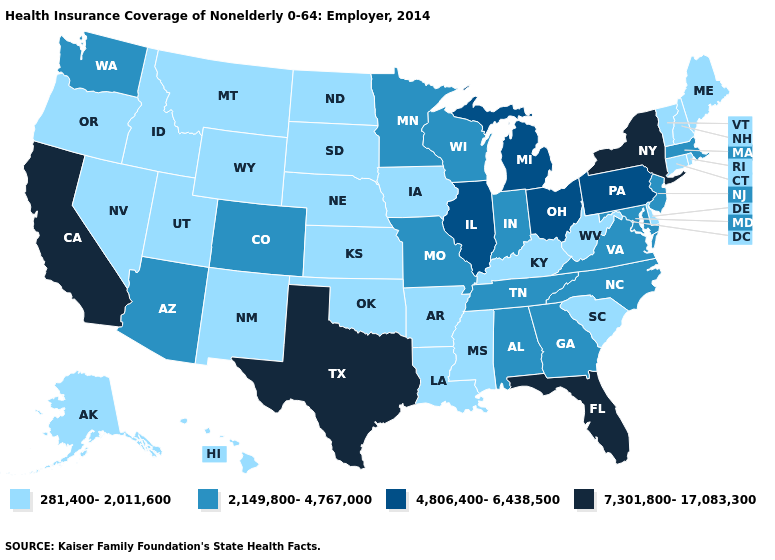Among the states that border Connecticut , does Rhode Island have the lowest value?
Write a very short answer. Yes. Which states have the lowest value in the South?
Concise answer only. Arkansas, Delaware, Kentucky, Louisiana, Mississippi, Oklahoma, South Carolina, West Virginia. Does Florida have the highest value in the South?
Be succinct. Yes. What is the value of New Mexico?
Concise answer only. 281,400-2,011,600. Which states have the highest value in the USA?
Be succinct. California, Florida, New York, Texas. Among the states that border Minnesota , which have the lowest value?
Short answer required. Iowa, North Dakota, South Dakota. What is the lowest value in states that border Wyoming?
Short answer required. 281,400-2,011,600. Does Iowa have the same value as California?
Write a very short answer. No. Does the map have missing data?
Be succinct. No. Among the states that border Nebraska , does Kansas have the highest value?
Keep it brief. No. Which states have the highest value in the USA?
Write a very short answer. California, Florida, New York, Texas. Name the states that have a value in the range 2,149,800-4,767,000?
Short answer required. Alabama, Arizona, Colorado, Georgia, Indiana, Maryland, Massachusetts, Minnesota, Missouri, New Jersey, North Carolina, Tennessee, Virginia, Washington, Wisconsin. Among the states that border Mississippi , does Alabama have the highest value?
Keep it brief. Yes. Name the states that have a value in the range 4,806,400-6,438,500?
Quick response, please. Illinois, Michigan, Ohio, Pennsylvania. 